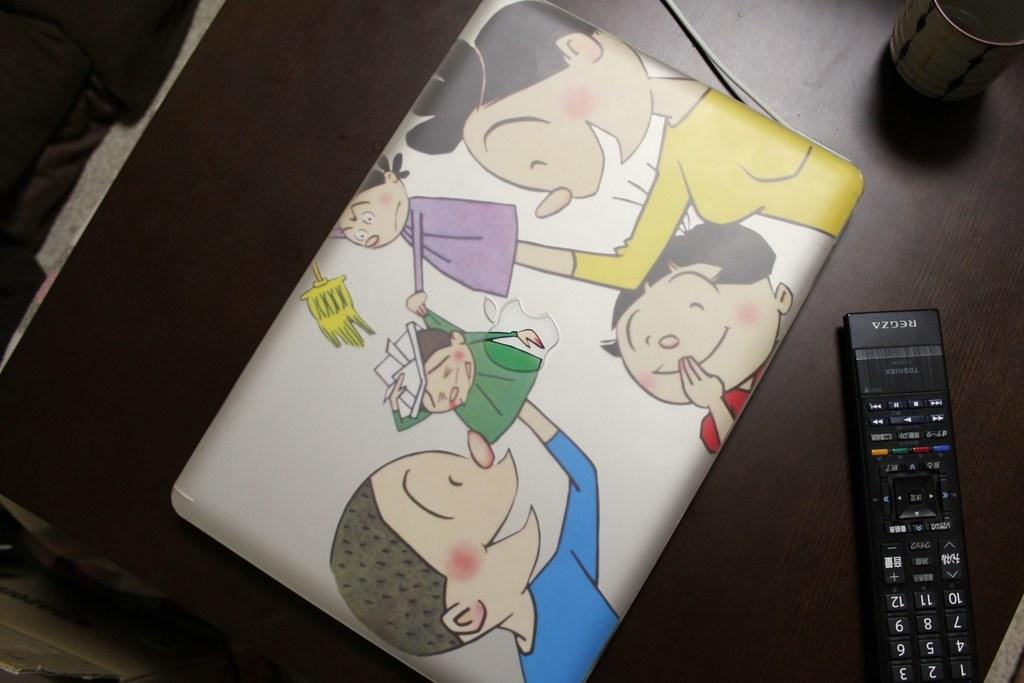<image>
Write a terse but informative summary of the picture. A Regza remote sits next to a laptop with illustrations. 